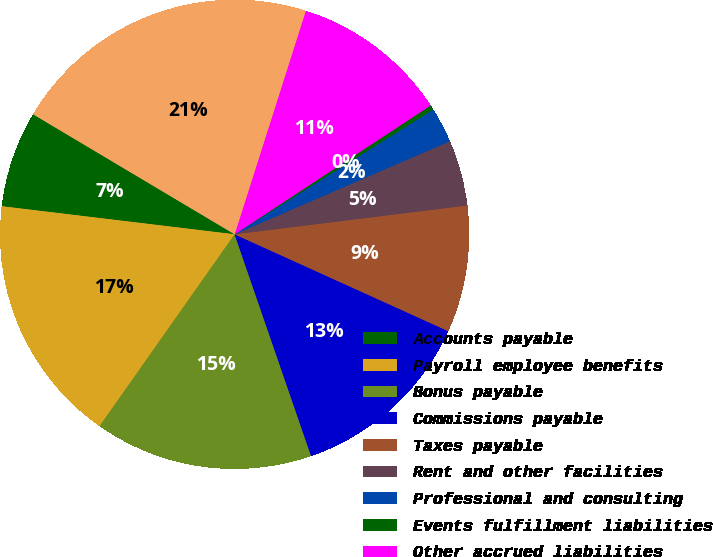Convert chart to OTSL. <chart><loc_0><loc_0><loc_500><loc_500><pie_chart><fcel>Accounts payable<fcel>Payroll employee benefits<fcel>Bonus payable<fcel>Commissions payable<fcel>Taxes payable<fcel>Rent and other facilities<fcel>Professional and consulting<fcel>Events fulfillment liabilities<fcel>Other accrued liabilities<fcel>Total accounts payable and<nl><fcel>6.64%<fcel>17.15%<fcel>15.05%<fcel>12.94%<fcel>8.74%<fcel>4.53%<fcel>2.43%<fcel>0.33%<fcel>10.84%<fcel>21.36%<nl></chart> 